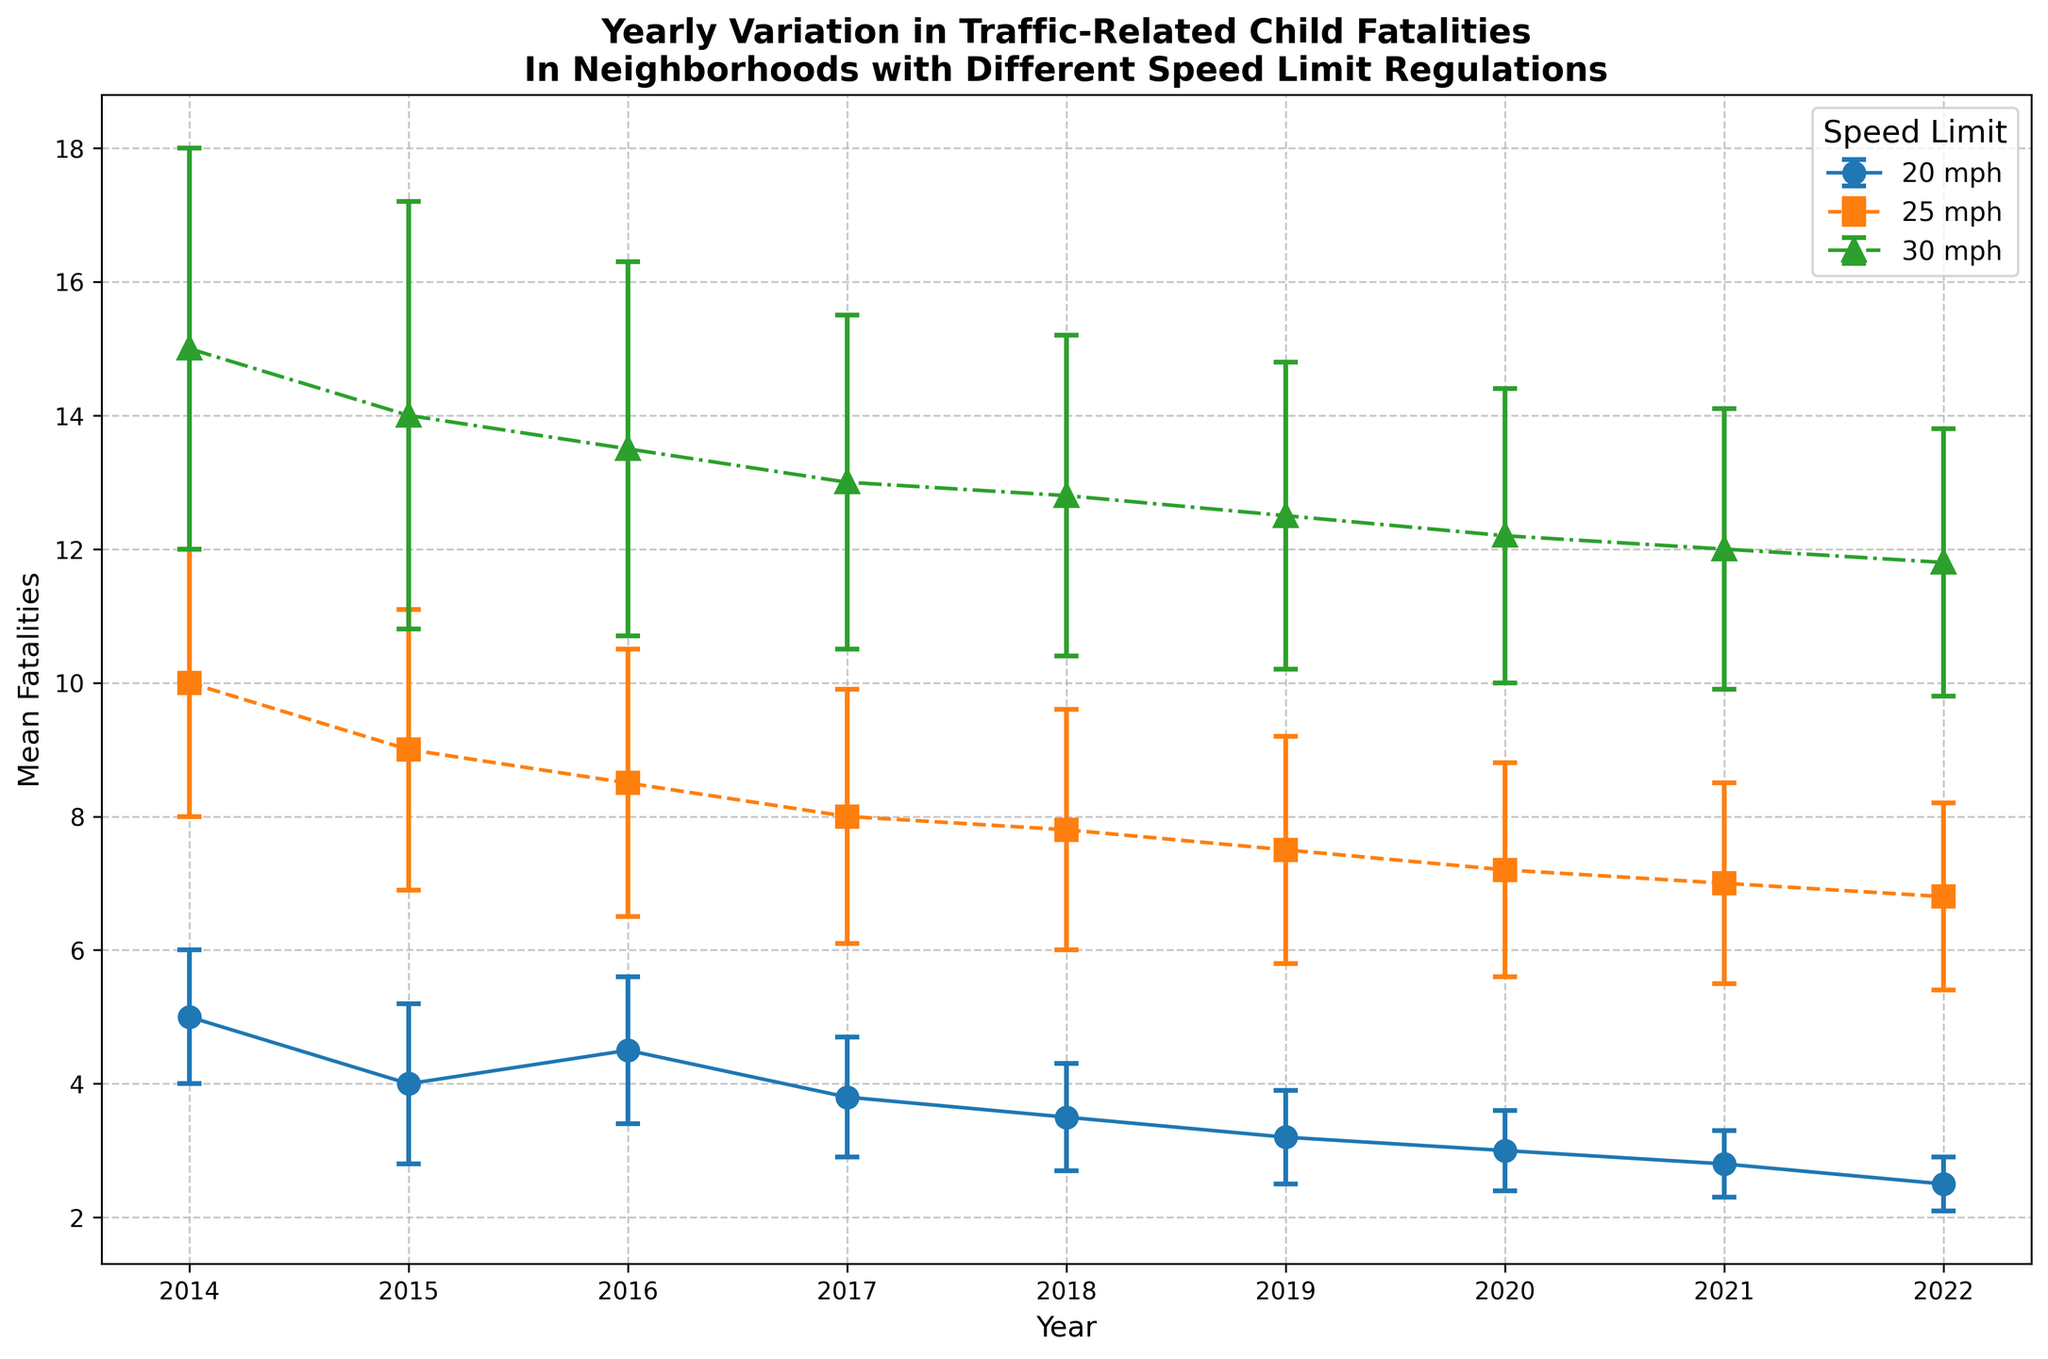How did the mean fatalities for neighborhoods with a 20 mph speed limit change from 2014 to 2022? In 2014, the mean fatalities for neighborhoods with a 20 mph speed limit were 5. In 2022, they dropped to 2.5. The change is 5 - 2.5.
Answer: 2.5 Which year showed the highest mean fatalities for the 25 mph speed limit? The highest mean fatalities for the 25 mph speed limit occurred in 2014, with a mean of 10 fatalities.
Answer: 2014 How do the error bars compare for the 30 mph speed limit in 2022 and 2014? In 2022, the standard deviation for the 30 mph speed limit was 2, while in 2014, it was 3. Thus, the error bars are smaller in 2022 than they were in 2014.
Answer: Smaller in 2022 What is the overall trend for mean fatalities in neighborhoods with a 20 mph speed limit from 2014 to 2022? The overall trend for mean fatalities in neighborhoods with a 20 mph speed limit from 2014 to 2022 is a steady decline.
Answer: Steady decline How did the mean fatalities for the 25 mph speed limit compare to the 30 mph speed limit in 2016? In 2016, the mean fatalities for the 25 mph speed limit were 8.5, while for the 30 mph speed limit, they were 13.5. Thus, the 30 mph speed limit had higher mean fatalities.
Answer: 30 mph had higher What is the difference in the mean fatalities between 20 mph and 25 mph speed limits in 2017? In 2017, mean fatalities for the 20 mph speed limit were 3.8, and for the 25 mph speed limit, they were 8. The difference is 8 - 3.8 = 4.2.
Answer: 4.2 Which speed limit saw the most significant reduction in mean fatalities from 2014 to 2022? The 20 mph speed limit saw the most significant reduction in mean fatalities, going from 5 in 2014 to 2.5 in 2022, a reduction of 2.5.
Answer: 20 mph What is the average mean fatalities for the 30 mph speed limit over the years 2018 to 2020? The mean fatalities for the 30 mph speed limit were 12.8 in 2018, 12.5 in 2019, and 12.2 in 2020. The average is (12.8 + 12.5 + 12.2) / 3 = 12.5.
Answer: 12.5 In which year did neighborhoods with a 20 mph speed limit have a mean fatality rate lower than half of the mean fatality rate for a 30 mph speed limit in the same year? In 2022, the mean fatalities for the 20 mph speed limit were 2.5, and for the 30 mph speed limit, they were 11.8. Half of 11.8 is 5.9, which is greater than 2.5.
Answer: 2022 